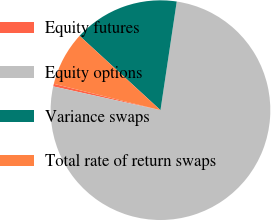<chart> <loc_0><loc_0><loc_500><loc_500><pie_chart><fcel>Equity futures<fcel>Equity options<fcel>Variance swaps<fcel>Total rate of return swaps<nl><fcel>0.39%<fcel>76.1%<fcel>15.54%<fcel>7.97%<nl></chart> 